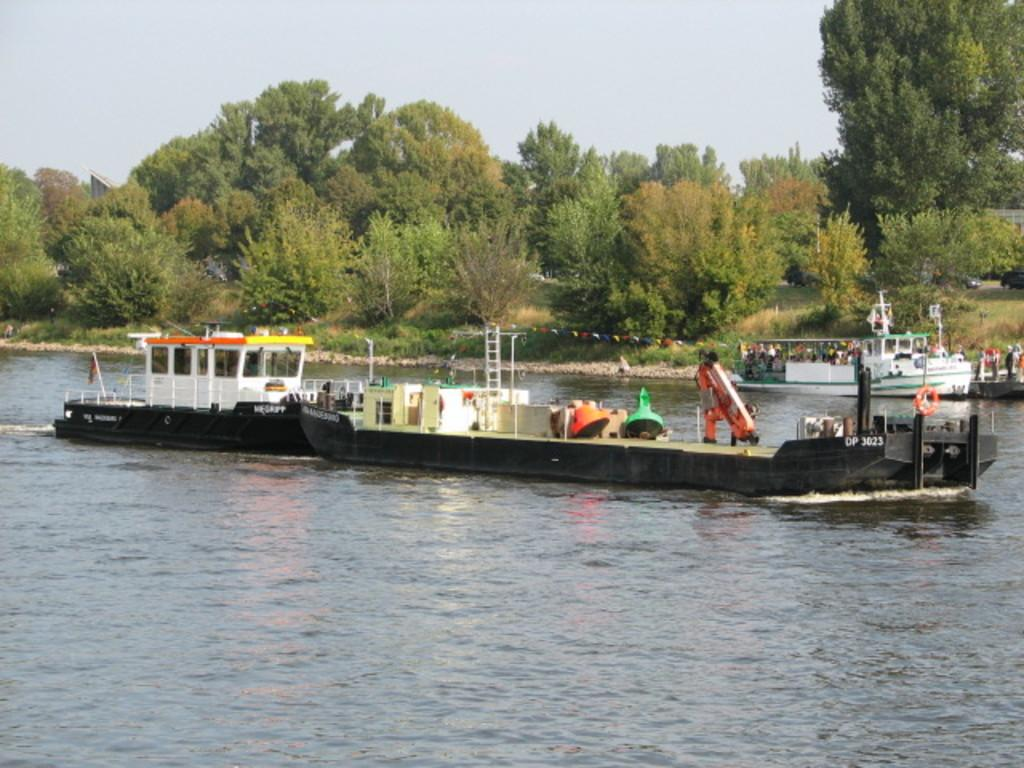What is on the water in the image? There are boats on the water in the image. Who is in the boats? There are people in the boats. What can be seen in the background of the image? There are trees visible in the background of the image. What type of salt can be seen hanging from the trees in the image? There is no salt visible in the image, nor is there any salt hanging from the trees. 